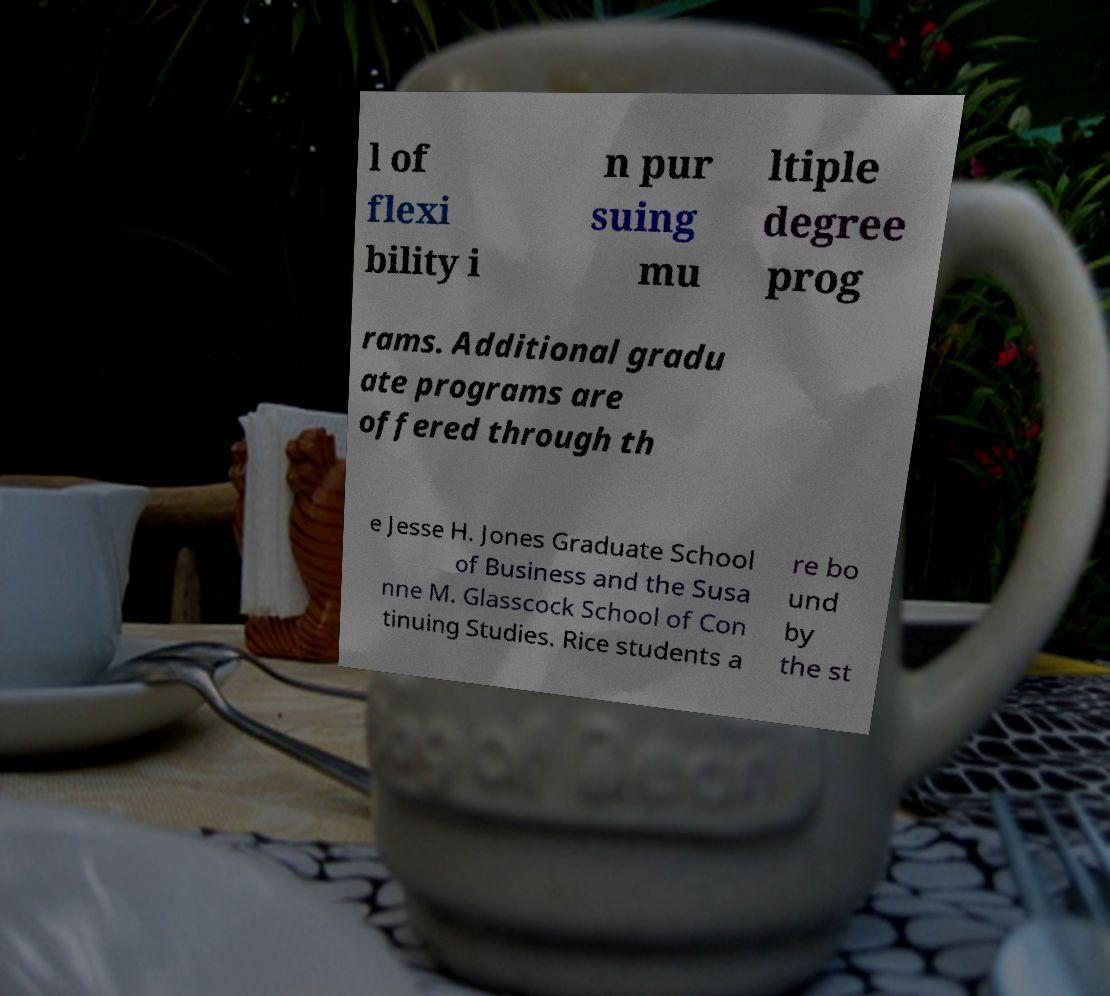Please identify and transcribe the text found in this image. l of flexi bility i n pur suing mu ltiple degree prog rams. Additional gradu ate programs are offered through th e Jesse H. Jones Graduate School of Business and the Susa nne M. Glasscock School of Con tinuing Studies. Rice students a re bo und by the st 